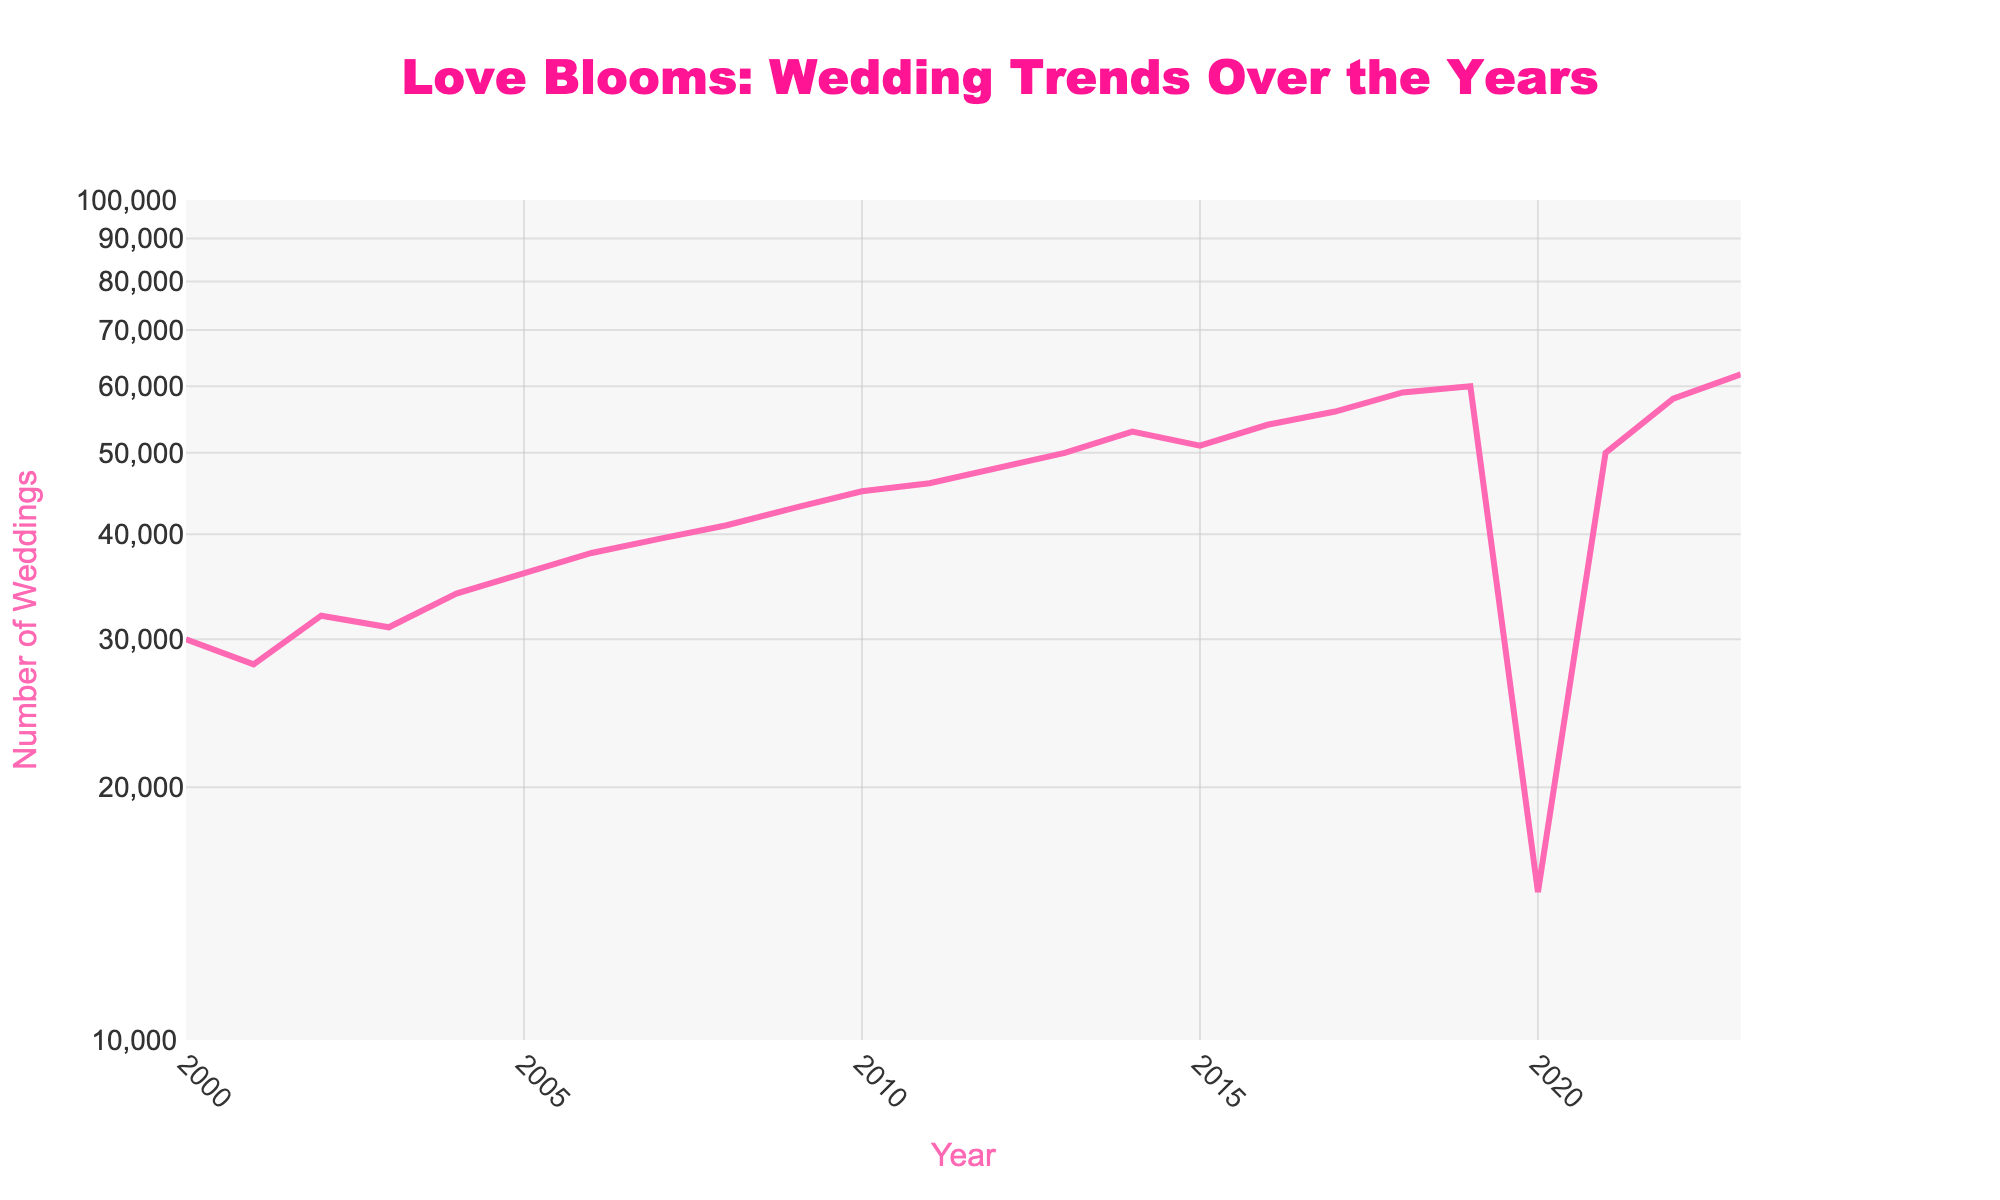What is the title of the figure? The title can be seen at the top center of the graph and reads "Love Blooms: Wedding Trends Over the Years" which describes the overall theme and focus of the plot.
Answer: "Love Blooms: Wedding Trends Over the Years" How many weddings were there in 2005? To find the number of weddings in 2005, locate the data point for the year 2005 on the x-axis and read the corresponding value on the y-axis. The number of weddings is 36,000.
Answer: 36,000 Which year had the lowest number of weddings? The lowest number is visually identifiable by locating the lowest point on the plot. The year 2020 had the lowest number of weddings with 15,000.
Answer: 2020 How did the number of weddings change from 2019 to 2020? Observe the data points for the years 2019 (60,000 weddings) and 2020 (15,000 weddings). The number of weddings dropped drastically by 45,000.
Answer: Decreased by 45,000 Which two consecutive years had the most significant increase in the number of weddings? Compare the year-over-year changes by looking at the steepness of the lines between consecutive years. Between 2020 and 2021, the weddings increased from 15,000 to 50,000, which is a jump of 35,000.
Answer: 2020 to 2021 What is the trend in the number of weddings from 2000 to 2019? By examining the years from 2000 to 2019, you can see a general upward trend with the number of weddings increasing from 30,000 to 60,000 over time.
Answer: Increasing What is the general trend observed in the number of weddings from 2020 to 2023? From the year 2020 to 2023, there is a significant recovery after the sharp drop in 2020, with the number rising from 15,000 back to 62,000.
Answer: Recovery What is the log scale range used for the y-axis in the figure? The y-axis is marked with a log scale ranging from approximately 10,000 to 100,000 weddings. This means the axis is scaled logarithmically.
Answer: 10,000 to 100,000 How did the number of weddings change from 2015 to 2016 compared to from 2018 to 2019? For 2015 to 2016, the number increased from 51,000 to 54,000 (an increase of 3,000). From 2018 to 2019, the number increased from 59,000 to 60,000 (an increase of 1,000). Thus, the increase was bigger from 2015 to 2016.
Answer: 2015 to 2016 had a larger increase How many years had over 50,000 weddings? By quickly inspecting the y-axis and the data points, the years with over 50,000 weddings are 2014, 2015, 2016, 2017, 2018, 2019, 2021, 2022, and 2023, totaling 9 years.
Answer: 9 years 